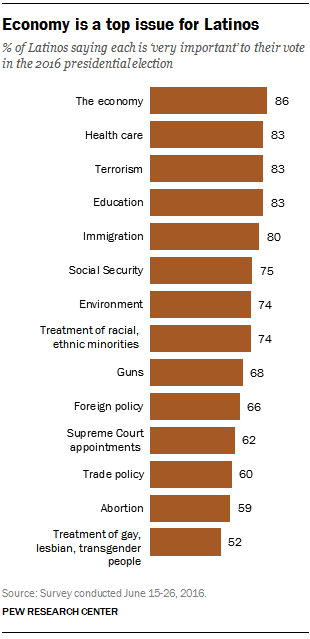Point out several critical features in this image. Out of the total number of bars displayed, how many have a rating of less than 80%? The results of the vote indicate that the majority of voters supported a certain number of issues, while the second most voted option had a different number of issues. Additionally, there are a total of [1, 3, 14] factors in these categories. 